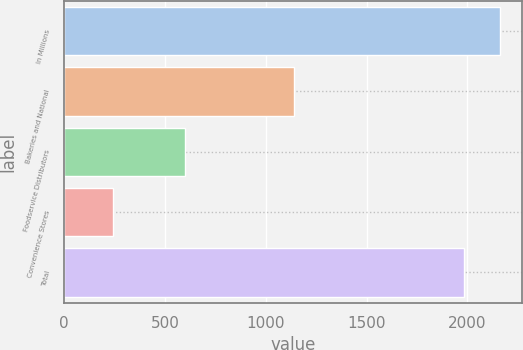<chart> <loc_0><loc_0><loc_500><loc_500><bar_chart><fcel>In Millions<fcel>Bakeries and National<fcel>Foodservice Distributors<fcel>Convenience Stores<fcel>Total<nl><fcel>2160.28<fcel>1138.8<fcel>601.4<fcel>243.2<fcel>1983.4<nl></chart> 